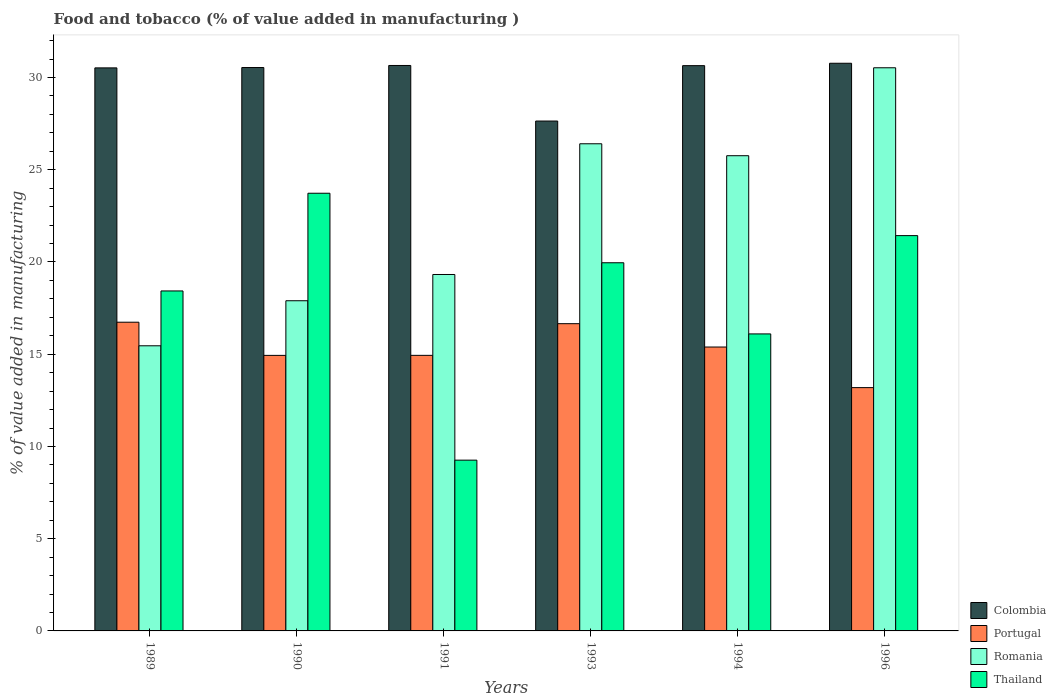How many different coloured bars are there?
Offer a terse response. 4. How many groups of bars are there?
Your answer should be very brief. 6. Are the number of bars per tick equal to the number of legend labels?
Your answer should be very brief. Yes. Are the number of bars on each tick of the X-axis equal?
Provide a succinct answer. Yes. How many bars are there on the 4th tick from the right?
Your answer should be compact. 4. What is the label of the 4th group of bars from the left?
Offer a very short reply. 1993. In how many cases, is the number of bars for a given year not equal to the number of legend labels?
Keep it short and to the point. 0. What is the value added in manufacturing food and tobacco in Colombia in 1993?
Offer a terse response. 27.64. Across all years, what is the maximum value added in manufacturing food and tobacco in Portugal?
Offer a terse response. 16.74. Across all years, what is the minimum value added in manufacturing food and tobacco in Colombia?
Ensure brevity in your answer.  27.64. In which year was the value added in manufacturing food and tobacco in Colombia maximum?
Provide a short and direct response. 1996. In which year was the value added in manufacturing food and tobacco in Romania minimum?
Provide a short and direct response. 1989. What is the total value added in manufacturing food and tobacco in Portugal in the graph?
Give a very brief answer. 91.85. What is the difference between the value added in manufacturing food and tobacco in Romania in 1993 and that in 1994?
Provide a short and direct response. 0.65. What is the difference between the value added in manufacturing food and tobacco in Thailand in 1989 and the value added in manufacturing food and tobacco in Colombia in 1996?
Your answer should be very brief. -12.34. What is the average value added in manufacturing food and tobacco in Thailand per year?
Your response must be concise. 18.15. In the year 1994, what is the difference between the value added in manufacturing food and tobacco in Romania and value added in manufacturing food and tobacco in Portugal?
Provide a succinct answer. 10.37. In how many years, is the value added in manufacturing food and tobacco in Colombia greater than 26 %?
Offer a very short reply. 6. What is the ratio of the value added in manufacturing food and tobacco in Thailand in 1990 to that in 1994?
Keep it short and to the point. 1.47. Is the value added in manufacturing food and tobacco in Colombia in 1990 less than that in 1991?
Ensure brevity in your answer.  Yes. Is the difference between the value added in manufacturing food and tobacco in Romania in 1991 and 1993 greater than the difference between the value added in manufacturing food and tobacco in Portugal in 1991 and 1993?
Offer a terse response. No. What is the difference between the highest and the second highest value added in manufacturing food and tobacco in Colombia?
Give a very brief answer. 0.12. What is the difference between the highest and the lowest value added in manufacturing food and tobacco in Thailand?
Keep it short and to the point. 14.47. Is the sum of the value added in manufacturing food and tobacco in Romania in 1989 and 1991 greater than the maximum value added in manufacturing food and tobacco in Colombia across all years?
Provide a succinct answer. Yes. What does the 4th bar from the left in 1994 represents?
Provide a short and direct response. Thailand. What does the 3rd bar from the right in 1990 represents?
Offer a terse response. Portugal. Is it the case that in every year, the sum of the value added in manufacturing food and tobacco in Colombia and value added in manufacturing food and tobacco in Romania is greater than the value added in manufacturing food and tobacco in Portugal?
Ensure brevity in your answer.  Yes. How many bars are there?
Provide a short and direct response. 24. Does the graph contain grids?
Provide a succinct answer. No. Where does the legend appear in the graph?
Give a very brief answer. Bottom right. How are the legend labels stacked?
Offer a terse response. Vertical. What is the title of the graph?
Your answer should be very brief. Food and tobacco (% of value added in manufacturing ). What is the label or title of the Y-axis?
Make the answer very short. % of value added in manufacturing. What is the % of value added in manufacturing in Colombia in 1989?
Give a very brief answer. 30.52. What is the % of value added in manufacturing of Portugal in 1989?
Your answer should be very brief. 16.74. What is the % of value added in manufacturing in Romania in 1989?
Provide a succinct answer. 15.46. What is the % of value added in manufacturing in Thailand in 1989?
Provide a succinct answer. 18.43. What is the % of value added in manufacturing of Colombia in 1990?
Your answer should be compact. 30.54. What is the % of value added in manufacturing in Portugal in 1990?
Your answer should be very brief. 14.94. What is the % of value added in manufacturing in Romania in 1990?
Keep it short and to the point. 17.9. What is the % of value added in manufacturing of Thailand in 1990?
Your answer should be very brief. 23.73. What is the % of value added in manufacturing in Colombia in 1991?
Make the answer very short. 30.65. What is the % of value added in manufacturing in Portugal in 1991?
Keep it short and to the point. 14.94. What is the % of value added in manufacturing of Romania in 1991?
Offer a terse response. 19.32. What is the % of value added in manufacturing of Thailand in 1991?
Provide a short and direct response. 9.26. What is the % of value added in manufacturing in Colombia in 1993?
Ensure brevity in your answer.  27.64. What is the % of value added in manufacturing in Portugal in 1993?
Make the answer very short. 16.66. What is the % of value added in manufacturing in Romania in 1993?
Provide a succinct answer. 26.41. What is the % of value added in manufacturing in Thailand in 1993?
Offer a very short reply. 19.96. What is the % of value added in manufacturing in Colombia in 1994?
Provide a short and direct response. 30.64. What is the % of value added in manufacturing in Portugal in 1994?
Your answer should be very brief. 15.39. What is the % of value added in manufacturing of Romania in 1994?
Offer a terse response. 25.76. What is the % of value added in manufacturing of Thailand in 1994?
Make the answer very short. 16.1. What is the % of value added in manufacturing of Colombia in 1996?
Your response must be concise. 30.77. What is the % of value added in manufacturing of Portugal in 1996?
Provide a succinct answer. 13.19. What is the % of value added in manufacturing in Romania in 1996?
Your answer should be very brief. 30.53. What is the % of value added in manufacturing of Thailand in 1996?
Offer a very short reply. 21.43. Across all years, what is the maximum % of value added in manufacturing in Colombia?
Provide a succinct answer. 30.77. Across all years, what is the maximum % of value added in manufacturing in Portugal?
Offer a very short reply. 16.74. Across all years, what is the maximum % of value added in manufacturing of Romania?
Keep it short and to the point. 30.53. Across all years, what is the maximum % of value added in manufacturing in Thailand?
Your response must be concise. 23.73. Across all years, what is the minimum % of value added in manufacturing in Colombia?
Make the answer very short. 27.64. Across all years, what is the minimum % of value added in manufacturing of Portugal?
Make the answer very short. 13.19. Across all years, what is the minimum % of value added in manufacturing of Romania?
Offer a terse response. 15.46. Across all years, what is the minimum % of value added in manufacturing of Thailand?
Provide a short and direct response. 9.26. What is the total % of value added in manufacturing in Colombia in the graph?
Offer a terse response. 180.77. What is the total % of value added in manufacturing in Portugal in the graph?
Provide a short and direct response. 91.85. What is the total % of value added in manufacturing of Romania in the graph?
Provide a short and direct response. 135.38. What is the total % of value added in manufacturing in Thailand in the graph?
Provide a succinct answer. 108.9. What is the difference between the % of value added in manufacturing of Colombia in 1989 and that in 1990?
Your answer should be compact. -0.02. What is the difference between the % of value added in manufacturing of Portugal in 1989 and that in 1990?
Offer a terse response. 1.8. What is the difference between the % of value added in manufacturing of Romania in 1989 and that in 1990?
Provide a succinct answer. -2.44. What is the difference between the % of value added in manufacturing of Thailand in 1989 and that in 1990?
Your response must be concise. -5.3. What is the difference between the % of value added in manufacturing in Colombia in 1989 and that in 1991?
Offer a very short reply. -0.13. What is the difference between the % of value added in manufacturing in Portugal in 1989 and that in 1991?
Offer a terse response. 1.8. What is the difference between the % of value added in manufacturing of Romania in 1989 and that in 1991?
Offer a very short reply. -3.87. What is the difference between the % of value added in manufacturing of Thailand in 1989 and that in 1991?
Make the answer very short. 9.17. What is the difference between the % of value added in manufacturing in Colombia in 1989 and that in 1993?
Your answer should be compact. 2.88. What is the difference between the % of value added in manufacturing in Portugal in 1989 and that in 1993?
Make the answer very short. 0.08. What is the difference between the % of value added in manufacturing of Romania in 1989 and that in 1993?
Offer a very short reply. -10.95. What is the difference between the % of value added in manufacturing in Thailand in 1989 and that in 1993?
Your answer should be very brief. -1.53. What is the difference between the % of value added in manufacturing of Colombia in 1989 and that in 1994?
Offer a very short reply. -0.12. What is the difference between the % of value added in manufacturing of Portugal in 1989 and that in 1994?
Your response must be concise. 1.34. What is the difference between the % of value added in manufacturing of Romania in 1989 and that in 1994?
Make the answer very short. -10.3. What is the difference between the % of value added in manufacturing of Thailand in 1989 and that in 1994?
Make the answer very short. 2.33. What is the difference between the % of value added in manufacturing in Colombia in 1989 and that in 1996?
Provide a short and direct response. -0.25. What is the difference between the % of value added in manufacturing of Portugal in 1989 and that in 1996?
Your answer should be very brief. 3.55. What is the difference between the % of value added in manufacturing of Romania in 1989 and that in 1996?
Your answer should be compact. -15.07. What is the difference between the % of value added in manufacturing of Thailand in 1989 and that in 1996?
Provide a short and direct response. -3. What is the difference between the % of value added in manufacturing in Colombia in 1990 and that in 1991?
Make the answer very short. -0.11. What is the difference between the % of value added in manufacturing in Portugal in 1990 and that in 1991?
Your answer should be very brief. -0. What is the difference between the % of value added in manufacturing in Romania in 1990 and that in 1991?
Provide a short and direct response. -1.42. What is the difference between the % of value added in manufacturing in Thailand in 1990 and that in 1991?
Your answer should be very brief. 14.47. What is the difference between the % of value added in manufacturing of Colombia in 1990 and that in 1993?
Give a very brief answer. 2.9. What is the difference between the % of value added in manufacturing of Portugal in 1990 and that in 1993?
Keep it short and to the point. -1.72. What is the difference between the % of value added in manufacturing of Romania in 1990 and that in 1993?
Your answer should be very brief. -8.51. What is the difference between the % of value added in manufacturing in Thailand in 1990 and that in 1993?
Ensure brevity in your answer.  3.77. What is the difference between the % of value added in manufacturing of Colombia in 1990 and that in 1994?
Offer a terse response. -0.1. What is the difference between the % of value added in manufacturing in Portugal in 1990 and that in 1994?
Keep it short and to the point. -0.45. What is the difference between the % of value added in manufacturing of Romania in 1990 and that in 1994?
Your answer should be compact. -7.86. What is the difference between the % of value added in manufacturing of Thailand in 1990 and that in 1994?
Make the answer very short. 7.63. What is the difference between the % of value added in manufacturing in Colombia in 1990 and that in 1996?
Ensure brevity in your answer.  -0.23. What is the difference between the % of value added in manufacturing of Portugal in 1990 and that in 1996?
Provide a short and direct response. 1.75. What is the difference between the % of value added in manufacturing of Romania in 1990 and that in 1996?
Offer a very short reply. -12.63. What is the difference between the % of value added in manufacturing in Thailand in 1990 and that in 1996?
Offer a terse response. 2.3. What is the difference between the % of value added in manufacturing in Colombia in 1991 and that in 1993?
Your response must be concise. 3.01. What is the difference between the % of value added in manufacturing of Portugal in 1991 and that in 1993?
Give a very brief answer. -1.72. What is the difference between the % of value added in manufacturing of Romania in 1991 and that in 1993?
Make the answer very short. -7.09. What is the difference between the % of value added in manufacturing in Thailand in 1991 and that in 1993?
Your answer should be compact. -10.7. What is the difference between the % of value added in manufacturing in Colombia in 1991 and that in 1994?
Make the answer very short. 0.01. What is the difference between the % of value added in manufacturing of Portugal in 1991 and that in 1994?
Provide a succinct answer. -0.45. What is the difference between the % of value added in manufacturing of Romania in 1991 and that in 1994?
Ensure brevity in your answer.  -6.44. What is the difference between the % of value added in manufacturing in Thailand in 1991 and that in 1994?
Your answer should be very brief. -6.84. What is the difference between the % of value added in manufacturing in Colombia in 1991 and that in 1996?
Your answer should be compact. -0.12. What is the difference between the % of value added in manufacturing in Portugal in 1991 and that in 1996?
Provide a succinct answer. 1.75. What is the difference between the % of value added in manufacturing in Romania in 1991 and that in 1996?
Ensure brevity in your answer.  -11.21. What is the difference between the % of value added in manufacturing of Thailand in 1991 and that in 1996?
Offer a terse response. -12.17. What is the difference between the % of value added in manufacturing of Colombia in 1993 and that in 1994?
Your answer should be very brief. -3. What is the difference between the % of value added in manufacturing in Portugal in 1993 and that in 1994?
Offer a very short reply. 1.26. What is the difference between the % of value added in manufacturing in Romania in 1993 and that in 1994?
Provide a succinct answer. 0.65. What is the difference between the % of value added in manufacturing in Thailand in 1993 and that in 1994?
Keep it short and to the point. 3.86. What is the difference between the % of value added in manufacturing of Colombia in 1993 and that in 1996?
Your answer should be compact. -3.13. What is the difference between the % of value added in manufacturing in Portugal in 1993 and that in 1996?
Give a very brief answer. 3.47. What is the difference between the % of value added in manufacturing of Romania in 1993 and that in 1996?
Ensure brevity in your answer.  -4.12. What is the difference between the % of value added in manufacturing in Thailand in 1993 and that in 1996?
Give a very brief answer. -1.47. What is the difference between the % of value added in manufacturing of Colombia in 1994 and that in 1996?
Provide a short and direct response. -0.13. What is the difference between the % of value added in manufacturing of Portugal in 1994 and that in 1996?
Provide a succinct answer. 2.2. What is the difference between the % of value added in manufacturing in Romania in 1994 and that in 1996?
Make the answer very short. -4.77. What is the difference between the % of value added in manufacturing in Thailand in 1994 and that in 1996?
Offer a terse response. -5.33. What is the difference between the % of value added in manufacturing of Colombia in 1989 and the % of value added in manufacturing of Portugal in 1990?
Offer a very short reply. 15.59. What is the difference between the % of value added in manufacturing in Colombia in 1989 and the % of value added in manufacturing in Romania in 1990?
Make the answer very short. 12.62. What is the difference between the % of value added in manufacturing of Colombia in 1989 and the % of value added in manufacturing of Thailand in 1990?
Ensure brevity in your answer.  6.8. What is the difference between the % of value added in manufacturing in Portugal in 1989 and the % of value added in manufacturing in Romania in 1990?
Your answer should be very brief. -1.16. What is the difference between the % of value added in manufacturing in Portugal in 1989 and the % of value added in manufacturing in Thailand in 1990?
Make the answer very short. -6.99. What is the difference between the % of value added in manufacturing in Romania in 1989 and the % of value added in manufacturing in Thailand in 1990?
Provide a short and direct response. -8.27. What is the difference between the % of value added in manufacturing in Colombia in 1989 and the % of value added in manufacturing in Portugal in 1991?
Ensure brevity in your answer.  15.58. What is the difference between the % of value added in manufacturing in Colombia in 1989 and the % of value added in manufacturing in Romania in 1991?
Keep it short and to the point. 11.2. What is the difference between the % of value added in manufacturing of Colombia in 1989 and the % of value added in manufacturing of Thailand in 1991?
Provide a short and direct response. 21.26. What is the difference between the % of value added in manufacturing in Portugal in 1989 and the % of value added in manufacturing in Romania in 1991?
Provide a succinct answer. -2.59. What is the difference between the % of value added in manufacturing in Portugal in 1989 and the % of value added in manufacturing in Thailand in 1991?
Your answer should be compact. 7.48. What is the difference between the % of value added in manufacturing in Romania in 1989 and the % of value added in manufacturing in Thailand in 1991?
Provide a succinct answer. 6.2. What is the difference between the % of value added in manufacturing in Colombia in 1989 and the % of value added in manufacturing in Portugal in 1993?
Your response must be concise. 13.87. What is the difference between the % of value added in manufacturing of Colombia in 1989 and the % of value added in manufacturing of Romania in 1993?
Ensure brevity in your answer.  4.11. What is the difference between the % of value added in manufacturing in Colombia in 1989 and the % of value added in manufacturing in Thailand in 1993?
Your response must be concise. 10.56. What is the difference between the % of value added in manufacturing in Portugal in 1989 and the % of value added in manufacturing in Romania in 1993?
Your answer should be compact. -9.67. What is the difference between the % of value added in manufacturing in Portugal in 1989 and the % of value added in manufacturing in Thailand in 1993?
Provide a succinct answer. -3.22. What is the difference between the % of value added in manufacturing of Romania in 1989 and the % of value added in manufacturing of Thailand in 1993?
Offer a terse response. -4.5. What is the difference between the % of value added in manufacturing of Colombia in 1989 and the % of value added in manufacturing of Portugal in 1994?
Offer a terse response. 15.13. What is the difference between the % of value added in manufacturing of Colombia in 1989 and the % of value added in manufacturing of Romania in 1994?
Provide a succinct answer. 4.76. What is the difference between the % of value added in manufacturing in Colombia in 1989 and the % of value added in manufacturing in Thailand in 1994?
Ensure brevity in your answer.  14.42. What is the difference between the % of value added in manufacturing of Portugal in 1989 and the % of value added in manufacturing of Romania in 1994?
Provide a succinct answer. -9.03. What is the difference between the % of value added in manufacturing in Portugal in 1989 and the % of value added in manufacturing in Thailand in 1994?
Your answer should be very brief. 0.63. What is the difference between the % of value added in manufacturing of Romania in 1989 and the % of value added in manufacturing of Thailand in 1994?
Offer a terse response. -0.64. What is the difference between the % of value added in manufacturing in Colombia in 1989 and the % of value added in manufacturing in Portugal in 1996?
Your answer should be very brief. 17.33. What is the difference between the % of value added in manufacturing in Colombia in 1989 and the % of value added in manufacturing in Romania in 1996?
Your response must be concise. -0.01. What is the difference between the % of value added in manufacturing in Colombia in 1989 and the % of value added in manufacturing in Thailand in 1996?
Ensure brevity in your answer.  9.09. What is the difference between the % of value added in manufacturing in Portugal in 1989 and the % of value added in manufacturing in Romania in 1996?
Your answer should be very brief. -13.79. What is the difference between the % of value added in manufacturing of Portugal in 1989 and the % of value added in manufacturing of Thailand in 1996?
Your response must be concise. -4.69. What is the difference between the % of value added in manufacturing in Romania in 1989 and the % of value added in manufacturing in Thailand in 1996?
Provide a succinct answer. -5.97. What is the difference between the % of value added in manufacturing of Colombia in 1990 and the % of value added in manufacturing of Portugal in 1991?
Keep it short and to the point. 15.6. What is the difference between the % of value added in manufacturing in Colombia in 1990 and the % of value added in manufacturing in Romania in 1991?
Offer a terse response. 11.22. What is the difference between the % of value added in manufacturing of Colombia in 1990 and the % of value added in manufacturing of Thailand in 1991?
Your response must be concise. 21.28. What is the difference between the % of value added in manufacturing of Portugal in 1990 and the % of value added in manufacturing of Romania in 1991?
Offer a very short reply. -4.39. What is the difference between the % of value added in manufacturing in Portugal in 1990 and the % of value added in manufacturing in Thailand in 1991?
Your answer should be very brief. 5.68. What is the difference between the % of value added in manufacturing of Romania in 1990 and the % of value added in manufacturing of Thailand in 1991?
Make the answer very short. 8.64. What is the difference between the % of value added in manufacturing in Colombia in 1990 and the % of value added in manufacturing in Portugal in 1993?
Your response must be concise. 13.89. What is the difference between the % of value added in manufacturing of Colombia in 1990 and the % of value added in manufacturing of Romania in 1993?
Make the answer very short. 4.13. What is the difference between the % of value added in manufacturing in Colombia in 1990 and the % of value added in manufacturing in Thailand in 1993?
Give a very brief answer. 10.58. What is the difference between the % of value added in manufacturing in Portugal in 1990 and the % of value added in manufacturing in Romania in 1993?
Your response must be concise. -11.47. What is the difference between the % of value added in manufacturing of Portugal in 1990 and the % of value added in manufacturing of Thailand in 1993?
Keep it short and to the point. -5.02. What is the difference between the % of value added in manufacturing in Romania in 1990 and the % of value added in manufacturing in Thailand in 1993?
Provide a succinct answer. -2.06. What is the difference between the % of value added in manufacturing in Colombia in 1990 and the % of value added in manufacturing in Portugal in 1994?
Your answer should be compact. 15.15. What is the difference between the % of value added in manufacturing of Colombia in 1990 and the % of value added in manufacturing of Romania in 1994?
Offer a very short reply. 4.78. What is the difference between the % of value added in manufacturing in Colombia in 1990 and the % of value added in manufacturing in Thailand in 1994?
Your response must be concise. 14.44. What is the difference between the % of value added in manufacturing of Portugal in 1990 and the % of value added in manufacturing of Romania in 1994?
Make the answer very short. -10.82. What is the difference between the % of value added in manufacturing of Portugal in 1990 and the % of value added in manufacturing of Thailand in 1994?
Ensure brevity in your answer.  -1.16. What is the difference between the % of value added in manufacturing in Romania in 1990 and the % of value added in manufacturing in Thailand in 1994?
Make the answer very short. 1.8. What is the difference between the % of value added in manufacturing in Colombia in 1990 and the % of value added in manufacturing in Portugal in 1996?
Provide a succinct answer. 17.35. What is the difference between the % of value added in manufacturing of Colombia in 1990 and the % of value added in manufacturing of Romania in 1996?
Give a very brief answer. 0.01. What is the difference between the % of value added in manufacturing in Colombia in 1990 and the % of value added in manufacturing in Thailand in 1996?
Keep it short and to the point. 9.11. What is the difference between the % of value added in manufacturing of Portugal in 1990 and the % of value added in manufacturing of Romania in 1996?
Ensure brevity in your answer.  -15.59. What is the difference between the % of value added in manufacturing in Portugal in 1990 and the % of value added in manufacturing in Thailand in 1996?
Your answer should be compact. -6.49. What is the difference between the % of value added in manufacturing of Romania in 1990 and the % of value added in manufacturing of Thailand in 1996?
Make the answer very short. -3.53. What is the difference between the % of value added in manufacturing of Colombia in 1991 and the % of value added in manufacturing of Portugal in 1993?
Your response must be concise. 14. What is the difference between the % of value added in manufacturing in Colombia in 1991 and the % of value added in manufacturing in Romania in 1993?
Ensure brevity in your answer.  4.24. What is the difference between the % of value added in manufacturing of Colombia in 1991 and the % of value added in manufacturing of Thailand in 1993?
Make the answer very short. 10.69. What is the difference between the % of value added in manufacturing in Portugal in 1991 and the % of value added in manufacturing in Romania in 1993?
Ensure brevity in your answer.  -11.47. What is the difference between the % of value added in manufacturing of Portugal in 1991 and the % of value added in manufacturing of Thailand in 1993?
Keep it short and to the point. -5.02. What is the difference between the % of value added in manufacturing of Romania in 1991 and the % of value added in manufacturing of Thailand in 1993?
Give a very brief answer. -0.64. What is the difference between the % of value added in manufacturing of Colombia in 1991 and the % of value added in manufacturing of Portugal in 1994?
Your response must be concise. 15.26. What is the difference between the % of value added in manufacturing of Colombia in 1991 and the % of value added in manufacturing of Romania in 1994?
Make the answer very short. 4.89. What is the difference between the % of value added in manufacturing of Colombia in 1991 and the % of value added in manufacturing of Thailand in 1994?
Provide a succinct answer. 14.55. What is the difference between the % of value added in manufacturing of Portugal in 1991 and the % of value added in manufacturing of Romania in 1994?
Ensure brevity in your answer.  -10.82. What is the difference between the % of value added in manufacturing in Portugal in 1991 and the % of value added in manufacturing in Thailand in 1994?
Offer a terse response. -1.16. What is the difference between the % of value added in manufacturing in Romania in 1991 and the % of value added in manufacturing in Thailand in 1994?
Make the answer very short. 3.22. What is the difference between the % of value added in manufacturing of Colombia in 1991 and the % of value added in manufacturing of Portugal in 1996?
Make the answer very short. 17.46. What is the difference between the % of value added in manufacturing in Colombia in 1991 and the % of value added in manufacturing in Romania in 1996?
Ensure brevity in your answer.  0.12. What is the difference between the % of value added in manufacturing of Colombia in 1991 and the % of value added in manufacturing of Thailand in 1996?
Ensure brevity in your answer.  9.22. What is the difference between the % of value added in manufacturing in Portugal in 1991 and the % of value added in manufacturing in Romania in 1996?
Your answer should be compact. -15.59. What is the difference between the % of value added in manufacturing in Portugal in 1991 and the % of value added in manufacturing in Thailand in 1996?
Offer a terse response. -6.49. What is the difference between the % of value added in manufacturing in Romania in 1991 and the % of value added in manufacturing in Thailand in 1996?
Ensure brevity in your answer.  -2.11. What is the difference between the % of value added in manufacturing in Colombia in 1993 and the % of value added in manufacturing in Portugal in 1994?
Keep it short and to the point. 12.25. What is the difference between the % of value added in manufacturing of Colombia in 1993 and the % of value added in manufacturing of Romania in 1994?
Offer a terse response. 1.88. What is the difference between the % of value added in manufacturing of Colombia in 1993 and the % of value added in manufacturing of Thailand in 1994?
Give a very brief answer. 11.54. What is the difference between the % of value added in manufacturing of Portugal in 1993 and the % of value added in manufacturing of Romania in 1994?
Give a very brief answer. -9.11. What is the difference between the % of value added in manufacturing of Portugal in 1993 and the % of value added in manufacturing of Thailand in 1994?
Provide a short and direct response. 0.55. What is the difference between the % of value added in manufacturing in Romania in 1993 and the % of value added in manufacturing in Thailand in 1994?
Provide a short and direct response. 10.31. What is the difference between the % of value added in manufacturing in Colombia in 1993 and the % of value added in manufacturing in Portugal in 1996?
Offer a very short reply. 14.45. What is the difference between the % of value added in manufacturing of Colombia in 1993 and the % of value added in manufacturing of Romania in 1996?
Give a very brief answer. -2.89. What is the difference between the % of value added in manufacturing of Colombia in 1993 and the % of value added in manufacturing of Thailand in 1996?
Ensure brevity in your answer.  6.21. What is the difference between the % of value added in manufacturing in Portugal in 1993 and the % of value added in manufacturing in Romania in 1996?
Provide a short and direct response. -13.87. What is the difference between the % of value added in manufacturing of Portugal in 1993 and the % of value added in manufacturing of Thailand in 1996?
Give a very brief answer. -4.77. What is the difference between the % of value added in manufacturing of Romania in 1993 and the % of value added in manufacturing of Thailand in 1996?
Ensure brevity in your answer.  4.98. What is the difference between the % of value added in manufacturing in Colombia in 1994 and the % of value added in manufacturing in Portugal in 1996?
Keep it short and to the point. 17.45. What is the difference between the % of value added in manufacturing of Colombia in 1994 and the % of value added in manufacturing of Romania in 1996?
Keep it short and to the point. 0.12. What is the difference between the % of value added in manufacturing in Colombia in 1994 and the % of value added in manufacturing in Thailand in 1996?
Offer a very short reply. 9.21. What is the difference between the % of value added in manufacturing of Portugal in 1994 and the % of value added in manufacturing of Romania in 1996?
Your response must be concise. -15.14. What is the difference between the % of value added in manufacturing in Portugal in 1994 and the % of value added in manufacturing in Thailand in 1996?
Your response must be concise. -6.04. What is the difference between the % of value added in manufacturing in Romania in 1994 and the % of value added in manufacturing in Thailand in 1996?
Ensure brevity in your answer.  4.33. What is the average % of value added in manufacturing in Colombia per year?
Provide a short and direct response. 30.13. What is the average % of value added in manufacturing in Portugal per year?
Give a very brief answer. 15.31. What is the average % of value added in manufacturing of Romania per year?
Your response must be concise. 22.56. What is the average % of value added in manufacturing of Thailand per year?
Provide a succinct answer. 18.15. In the year 1989, what is the difference between the % of value added in manufacturing in Colombia and % of value added in manufacturing in Portugal?
Your response must be concise. 13.79. In the year 1989, what is the difference between the % of value added in manufacturing in Colombia and % of value added in manufacturing in Romania?
Make the answer very short. 15.07. In the year 1989, what is the difference between the % of value added in manufacturing of Colombia and % of value added in manufacturing of Thailand?
Ensure brevity in your answer.  12.09. In the year 1989, what is the difference between the % of value added in manufacturing of Portugal and % of value added in manufacturing of Romania?
Keep it short and to the point. 1.28. In the year 1989, what is the difference between the % of value added in manufacturing in Portugal and % of value added in manufacturing in Thailand?
Keep it short and to the point. -1.7. In the year 1989, what is the difference between the % of value added in manufacturing in Romania and % of value added in manufacturing in Thailand?
Offer a very short reply. -2.97. In the year 1990, what is the difference between the % of value added in manufacturing of Colombia and % of value added in manufacturing of Portugal?
Keep it short and to the point. 15.6. In the year 1990, what is the difference between the % of value added in manufacturing of Colombia and % of value added in manufacturing of Romania?
Offer a terse response. 12.64. In the year 1990, what is the difference between the % of value added in manufacturing in Colombia and % of value added in manufacturing in Thailand?
Keep it short and to the point. 6.81. In the year 1990, what is the difference between the % of value added in manufacturing of Portugal and % of value added in manufacturing of Romania?
Give a very brief answer. -2.96. In the year 1990, what is the difference between the % of value added in manufacturing of Portugal and % of value added in manufacturing of Thailand?
Offer a very short reply. -8.79. In the year 1990, what is the difference between the % of value added in manufacturing of Romania and % of value added in manufacturing of Thailand?
Your answer should be compact. -5.83. In the year 1991, what is the difference between the % of value added in manufacturing of Colombia and % of value added in manufacturing of Portugal?
Your answer should be compact. 15.71. In the year 1991, what is the difference between the % of value added in manufacturing in Colombia and % of value added in manufacturing in Romania?
Your answer should be compact. 11.33. In the year 1991, what is the difference between the % of value added in manufacturing in Colombia and % of value added in manufacturing in Thailand?
Give a very brief answer. 21.4. In the year 1991, what is the difference between the % of value added in manufacturing of Portugal and % of value added in manufacturing of Romania?
Your answer should be very brief. -4.38. In the year 1991, what is the difference between the % of value added in manufacturing in Portugal and % of value added in manufacturing in Thailand?
Ensure brevity in your answer.  5.68. In the year 1991, what is the difference between the % of value added in manufacturing of Romania and % of value added in manufacturing of Thailand?
Provide a short and direct response. 10.06. In the year 1993, what is the difference between the % of value added in manufacturing in Colombia and % of value added in manufacturing in Portugal?
Ensure brevity in your answer.  10.99. In the year 1993, what is the difference between the % of value added in manufacturing in Colombia and % of value added in manufacturing in Romania?
Your answer should be compact. 1.23. In the year 1993, what is the difference between the % of value added in manufacturing of Colombia and % of value added in manufacturing of Thailand?
Your answer should be very brief. 7.68. In the year 1993, what is the difference between the % of value added in manufacturing of Portugal and % of value added in manufacturing of Romania?
Give a very brief answer. -9.75. In the year 1993, what is the difference between the % of value added in manufacturing of Portugal and % of value added in manufacturing of Thailand?
Your answer should be compact. -3.3. In the year 1993, what is the difference between the % of value added in manufacturing of Romania and % of value added in manufacturing of Thailand?
Your response must be concise. 6.45. In the year 1994, what is the difference between the % of value added in manufacturing of Colombia and % of value added in manufacturing of Portugal?
Your response must be concise. 15.25. In the year 1994, what is the difference between the % of value added in manufacturing of Colombia and % of value added in manufacturing of Romania?
Provide a succinct answer. 4.88. In the year 1994, what is the difference between the % of value added in manufacturing of Colombia and % of value added in manufacturing of Thailand?
Your response must be concise. 14.54. In the year 1994, what is the difference between the % of value added in manufacturing in Portugal and % of value added in manufacturing in Romania?
Make the answer very short. -10.37. In the year 1994, what is the difference between the % of value added in manufacturing in Portugal and % of value added in manufacturing in Thailand?
Give a very brief answer. -0.71. In the year 1994, what is the difference between the % of value added in manufacturing in Romania and % of value added in manufacturing in Thailand?
Provide a succinct answer. 9.66. In the year 1996, what is the difference between the % of value added in manufacturing in Colombia and % of value added in manufacturing in Portugal?
Offer a very short reply. 17.58. In the year 1996, what is the difference between the % of value added in manufacturing in Colombia and % of value added in manufacturing in Romania?
Offer a very short reply. 0.24. In the year 1996, what is the difference between the % of value added in manufacturing of Colombia and % of value added in manufacturing of Thailand?
Your response must be concise. 9.34. In the year 1996, what is the difference between the % of value added in manufacturing of Portugal and % of value added in manufacturing of Romania?
Ensure brevity in your answer.  -17.34. In the year 1996, what is the difference between the % of value added in manufacturing in Portugal and % of value added in manufacturing in Thailand?
Provide a succinct answer. -8.24. In the year 1996, what is the difference between the % of value added in manufacturing in Romania and % of value added in manufacturing in Thailand?
Offer a very short reply. 9.1. What is the ratio of the % of value added in manufacturing in Colombia in 1989 to that in 1990?
Provide a succinct answer. 1. What is the ratio of the % of value added in manufacturing of Portugal in 1989 to that in 1990?
Provide a succinct answer. 1.12. What is the ratio of the % of value added in manufacturing in Romania in 1989 to that in 1990?
Provide a succinct answer. 0.86. What is the ratio of the % of value added in manufacturing in Thailand in 1989 to that in 1990?
Ensure brevity in your answer.  0.78. What is the ratio of the % of value added in manufacturing of Colombia in 1989 to that in 1991?
Offer a terse response. 1. What is the ratio of the % of value added in manufacturing of Portugal in 1989 to that in 1991?
Your answer should be compact. 1.12. What is the ratio of the % of value added in manufacturing in Romania in 1989 to that in 1991?
Your answer should be very brief. 0.8. What is the ratio of the % of value added in manufacturing of Thailand in 1989 to that in 1991?
Provide a succinct answer. 1.99. What is the ratio of the % of value added in manufacturing in Colombia in 1989 to that in 1993?
Offer a very short reply. 1.1. What is the ratio of the % of value added in manufacturing of Portugal in 1989 to that in 1993?
Provide a short and direct response. 1. What is the ratio of the % of value added in manufacturing of Romania in 1989 to that in 1993?
Make the answer very short. 0.59. What is the ratio of the % of value added in manufacturing in Thailand in 1989 to that in 1993?
Provide a short and direct response. 0.92. What is the ratio of the % of value added in manufacturing of Colombia in 1989 to that in 1994?
Your response must be concise. 1. What is the ratio of the % of value added in manufacturing in Portugal in 1989 to that in 1994?
Your answer should be very brief. 1.09. What is the ratio of the % of value added in manufacturing in Thailand in 1989 to that in 1994?
Provide a short and direct response. 1.14. What is the ratio of the % of value added in manufacturing in Colombia in 1989 to that in 1996?
Offer a very short reply. 0.99. What is the ratio of the % of value added in manufacturing of Portugal in 1989 to that in 1996?
Offer a very short reply. 1.27. What is the ratio of the % of value added in manufacturing in Romania in 1989 to that in 1996?
Offer a very short reply. 0.51. What is the ratio of the % of value added in manufacturing in Thailand in 1989 to that in 1996?
Give a very brief answer. 0.86. What is the ratio of the % of value added in manufacturing in Portugal in 1990 to that in 1991?
Make the answer very short. 1. What is the ratio of the % of value added in manufacturing in Romania in 1990 to that in 1991?
Your answer should be very brief. 0.93. What is the ratio of the % of value added in manufacturing in Thailand in 1990 to that in 1991?
Your answer should be very brief. 2.56. What is the ratio of the % of value added in manufacturing in Colombia in 1990 to that in 1993?
Provide a succinct answer. 1.1. What is the ratio of the % of value added in manufacturing in Portugal in 1990 to that in 1993?
Offer a terse response. 0.9. What is the ratio of the % of value added in manufacturing in Romania in 1990 to that in 1993?
Provide a succinct answer. 0.68. What is the ratio of the % of value added in manufacturing in Thailand in 1990 to that in 1993?
Your answer should be very brief. 1.19. What is the ratio of the % of value added in manufacturing of Colombia in 1990 to that in 1994?
Your response must be concise. 1. What is the ratio of the % of value added in manufacturing in Portugal in 1990 to that in 1994?
Your response must be concise. 0.97. What is the ratio of the % of value added in manufacturing of Romania in 1990 to that in 1994?
Give a very brief answer. 0.69. What is the ratio of the % of value added in manufacturing of Thailand in 1990 to that in 1994?
Your response must be concise. 1.47. What is the ratio of the % of value added in manufacturing of Colombia in 1990 to that in 1996?
Give a very brief answer. 0.99. What is the ratio of the % of value added in manufacturing of Portugal in 1990 to that in 1996?
Your answer should be very brief. 1.13. What is the ratio of the % of value added in manufacturing in Romania in 1990 to that in 1996?
Your answer should be compact. 0.59. What is the ratio of the % of value added in manufacturing in Thailand in 1990 to that in 1996?
Your answer should be very brief. 1.11. What is the ratio of the % of value added in manufacturing of Colombia in 1991 to that in 1993?
Ensure brevity in your answer.  1.11. What is the ratio of the % of value added in manufacturing of Portugal in 1991 to that in 1993?
Your response must be concise. 0.9. What is the ratio of the % of value added in manufacturing in Romania in 1991 to that in 1993?
Give a very brief answer. 0.73. What is the ratio of the % of value added in manufacturing in Thailand in 1991 to that in 1993?
Make the answer very short. 0.46. What is the ratio of the % of value added in manufacturing of Portugal in 1991 to that in 1994?
Ensure brevity in your answer.  0.97. What is the ratio of the % of value added in manufacturing in Romania in 1991 to that in 1994?
Your response must be concise. 0.75. What is the ratio of the % of value added in manufacturing of Thailand in 1991 to that in 1994?
Your response must be concise. 0.57. What is the ratio of the % of value added in manufacturing of Colombia in 1991 to that in 1996?
Ensure brevity in your answer.  1. What is the ratio of the % of value added in manufacturing of Portugal in 1991 to that in 1996?
Your answer should be very brief. 1.13. What is the ratio of the % of value added in manufacturing in Romania in 1991 to that in 1996?
Your answer should be very brief. 0.63. What is the ratio of the % of value added in manufacturing in Thailand in 1991 to that in 1996?
Offer a terse response. 0.43. What is the ratio of the % of value added in manufacturing of Colombia in 1993 to that in 1994?
Your answer should be compact. 0.9. What is the ratio of the % of value added in manufacturing of Portugal in 1993 to that in 1994?
Keep it short and to the point. 1.08. What is the ratio of the % of value added in manufacturing of Romania in 1993 to that in 1994?
Your answer should be compact. 1.03. What is the ratio of the % of value added in manufacturing in Thailand in 1993 to that in 1994?
Provide a short and direct response. 1.24. What is the ratio of the % of value added in manufacturing in Colombia in 1993 to that in 1996?
Your response must be concise. 0.9. What is the ratio of the % of value added in manufacturing of Portugal in 1993 to that in 1996?
Make the answer very short. 1.26. What is the ratio of the % of value added in manufacturing in Romania in 1993 to that in 1996?
Offer a very short reply. 0.86. What is the ratio of the % of value added in manufacturing of Thailand in 1993 to that in 1996?
Give a very brief answer. 0.93. What is the ratio of the % of value added in manufacturing in Portugal in 1994 to that in 1996?
Give a very brief answer. 1.17. What is the ratio of the % of value added in manufacturing of Romania in 1994 to that in 1996?
Offer a terse response. 0.84. What is the ratio of the % of value added in manufacturing in Thailand in 1994 to that in 1996?
Give a very brief answer. 0.75. What is the difference between the highest and the second highest % of value added in manufacturing in Colombia?
Your answer should be compact. 0.12. What is the difference between the highest and the second highest % of value added in manufacturing of Portugal?
Your answer should be very brief. 0.08. What is the difference between the highest and the second highest % of value added in manufacturing of Romania?
Provide a succinct answer. 4.12. What is the difference between the highest and the second highest % of value added in manufacturing in Thailand?
Offer a very short reply. 2.3. What is the difference between the highest and the lowest % of value added in manufacturing of Colombia?
Your response must be concise. 3.13. What is the difference between the highest and the lowest % of value added in manufacturing in Portugal?
Keep it short and to the point. 3.55. What is the difference between the highest and the lowest % of value added in manufacturing of Romania?
Provide a succinct answer. 15.07. What is the difference between the highest and the lowest % of value added in manufacturing of Thailand?
Your answer should be compact. 14.47. 